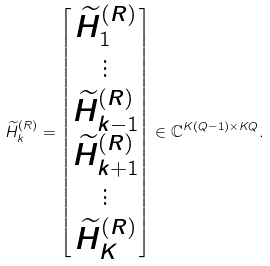Convert formula to latex. <formula><loc_0><loc_0><loc_500><loc_500>\widetilde { H } _ { k } ^ { ( R ) } = \begin{bmatrix} \widetilde { H } _ { 1 } ^ { ( R ) } \\ \vdots \\ \widetilde { H } _ { k - 1 } ^ { ( R ) } \\ \widetilde { H } _ { k + 1 } ^ { ( R ) } \\ \vdots \\ \widetilde { H } _ { K } ^ { ( R ) } \end{bmatrix} \in \mathbb { C } ^ { K ( Q - 1 ) \times K Q } .</formula> 